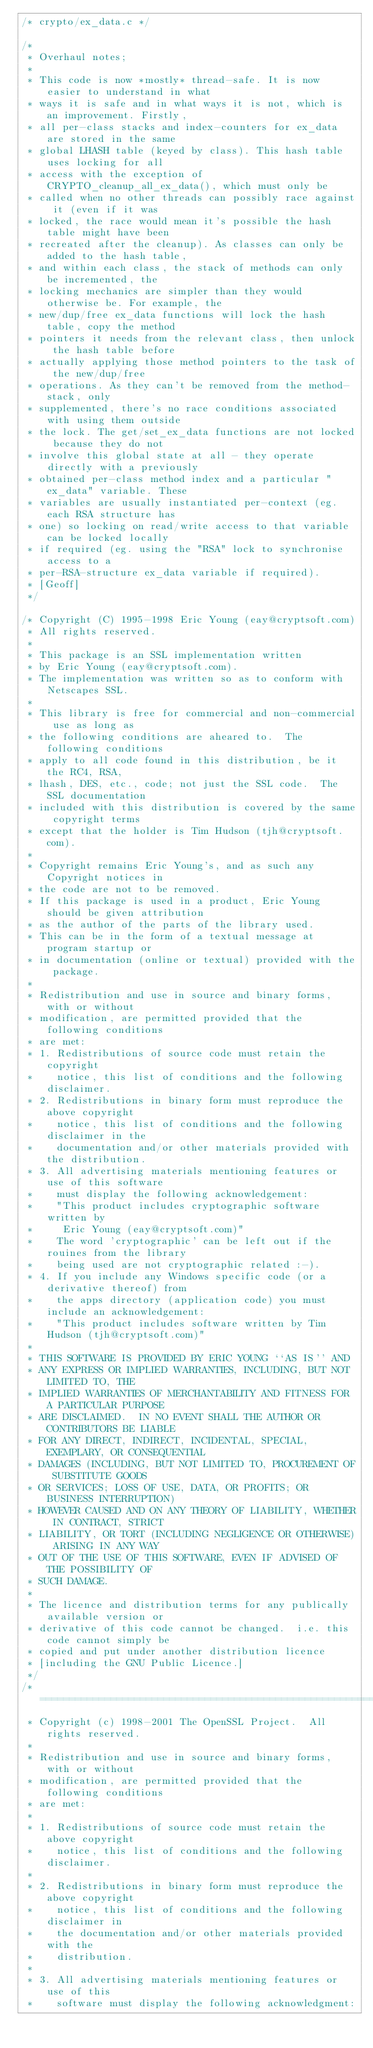Convert code to text. <code><loc_0><loc_0><loc_500><loc_500><_C_>/* crypto/ex_data.c */

/*
 * Overhaul notes;
 *
 * This code is now *mostly* thread-safe. It is now easier to understand in what
 * ways it is safe and in what ways it is not, which is an improvement. Firstly,
 * all per-class stacks and index-counters for ex_data are stored in the same
 * global LHASH table (keyed by class). This hash table uses locking for all
 * access with the exception of CRYPTO_cleanup_all_ex_data(), which must only be
 * called when no other threads can possibly race against it (even if it was
 * locked, the race would mean it's possible the hash table might have been
 * recreated after the cleanup). As classes can only be added to the hash table,
 * and within each class, the stack of methods can only be incremented, the
 * locking mechanics are simpler than they would otherwise be. For example, the
 * new/dup/free ex_data functions will lock the hash table, copy the method
 * pointers it needs from the relevant class, then unlock the hash table before
 * actually applying those method pointers to the task of the new/dup/free
 * operations. As they can't be removed from the method-stack, only
 * supplemented, there's no race conditions associated with using them outside
 * the lock. The get/set_ex_data functions are not locked because they do not
 * involve this global state at all - they operate directly with a previously
 * obtained per-class method index and a particular "ex_data" variable. These
 * variables are usually instantiated per-context (eg. each RSA structure has
 * one) so locking on read/write access to that variable can be locked locally
 * if required (eg. using the "RSA" lock to synchronise access to a
 * per-RSA-structure ex_data variable if required).
 * [Geoff]
 */

/* Copyright (C) 1995-1998 Eric Young (eay@cryptsoft.com)
 * All rights reserved.
 *
 * This package is an SSL implementation written
 * by Eric Young (eay@cryptsoft.com).
 * The implementation was written so as to conform with Netscapes SSL.
 *
 * This library is free for commercial and non-commercial use as long as
 * the following conditions are aheared to.  The following conditions
 * apply to all code found in this distribution, be it the RC4, RSA,
 * lhash, DES, etc., code; not just the SSL code.  The SSL documentation
 * included with this distribution is covered by the same copyright terms
 * except that the holder is Tim Hudson (tjh@cryptsoft.com).
 *
 * Copyright remains Eric Young's, and as such any Copyright notices in
 * the code are not to be removed.
 * If this package is used in a product, Eric Young should be given attribution
 * as the author of the parts of the library used.
 * This can be in the form of a textual message at program startup or
 * in documentation (online or textual) provided with the package.
 *
 * Redistribution and use in source and binary forms, with or without
 * modification, are permitted provided that the following conditions
 * are met:
 * 1. Redistributions of source code must retain the copyright
 *    notice, this list of conditions and the following disclaimer.
 * 2. Redistributions in binary form must reproduce the above copyright
 *    notice, this list of conditions and the following disclaimer in the
 *    documentation and/or other materials provided with the distribution.
 * 3. All advertising materials mentioning features or use of this software
 *    must display the following acknowledgement:
 *    "This product includes cryptographic software written by
 *     Eric Young (eay@cryptsoft.com)"
 *    The word 'cryptographic' can be left out if the rouines from the library
 *    being used are not cryptographic related :-).
 * 4. If you include any Windows specific code (or a derivative thereof) from
 *    the apps directory (application code) you must include an acknowledgement:
 *    "This product includes software written by Tim Hudson (tjh@cryptsoft.com)"
 *
 * THIS SOFTWARE IS PROVIDED BY ERIC YOUNG ``AS IS'' AND
 * ANY EXPRESS OR IMPLIED WARRANTIES, INCLUDING, BUT NOT LIMITED TO, THE
 * IMPLIED WARRANTIES OF MERCHANTABILITY AND FITNESS FOR A PARTICULAR PURPOSE
 * ARE DISCLAIMED.  IN NO EVENT SHALL THE AUTHOR OR CONTRIBUTORS BE LIABLE
 * FOR ANY DIRECT, INDIRECT, INCIDENTAL, SPECIAL, EXEMPLARY, OR CONSEQUENTIAL
 * DAMAGES (INCLUDING, BUT NOT LIMITED TO, PROCUREMENT OF SUBSTITUTE GOODS
 * OR SERVICES; LOSS OF USE, DATA, OR PROFITS; OR BUSINESS INTERRUPTION)
 * HOWEVER CAUSED AND ON ANY THEORY OF LIABILITY, WHETHER IN CONTRACT, STRICT
 * LIABILITY, OR TORT (INCLUDING NEGLIGENCE OR OTHERWISE) ARISING IN ANY WAY
 * OUT OF THE USE OF THIS SOFTWARE, EVEN IF ADVISED OF THE POSSIBILITY OF
 * SUCH DAMAGE.
 *
 * The licence and distribution terms for any publically available version or
 * derivative of this code cannot be changed.  i.e. this code cannot simply be
 * copied and put under another distribution licence
 * [including the GNU Public Licence.]
 */
/* ====================================================================
 * Copyright (c) 1998-2001 The OpenSSL Project.  All rights reserved.
 *
 * Redistribution and use in source and binary forms, with or without
 * modification, are permitted provided that the following conditions
 * are met:
 *
 * 1. Redistributions of source code must retain the above copyright
 *    notice, this list of conditions and the following disclaimer.
 *
 * 2. Redistributions in binary form must reproduce the above copyright
 *    notice, this list of conditions and the following disclaimer in
 *    the documentation and/or other materials provided with the
 *    distribution.
 *
 * 3. All advertising materials mentioning features or use of this
 *    software must display the following acknowledgment:</code> 